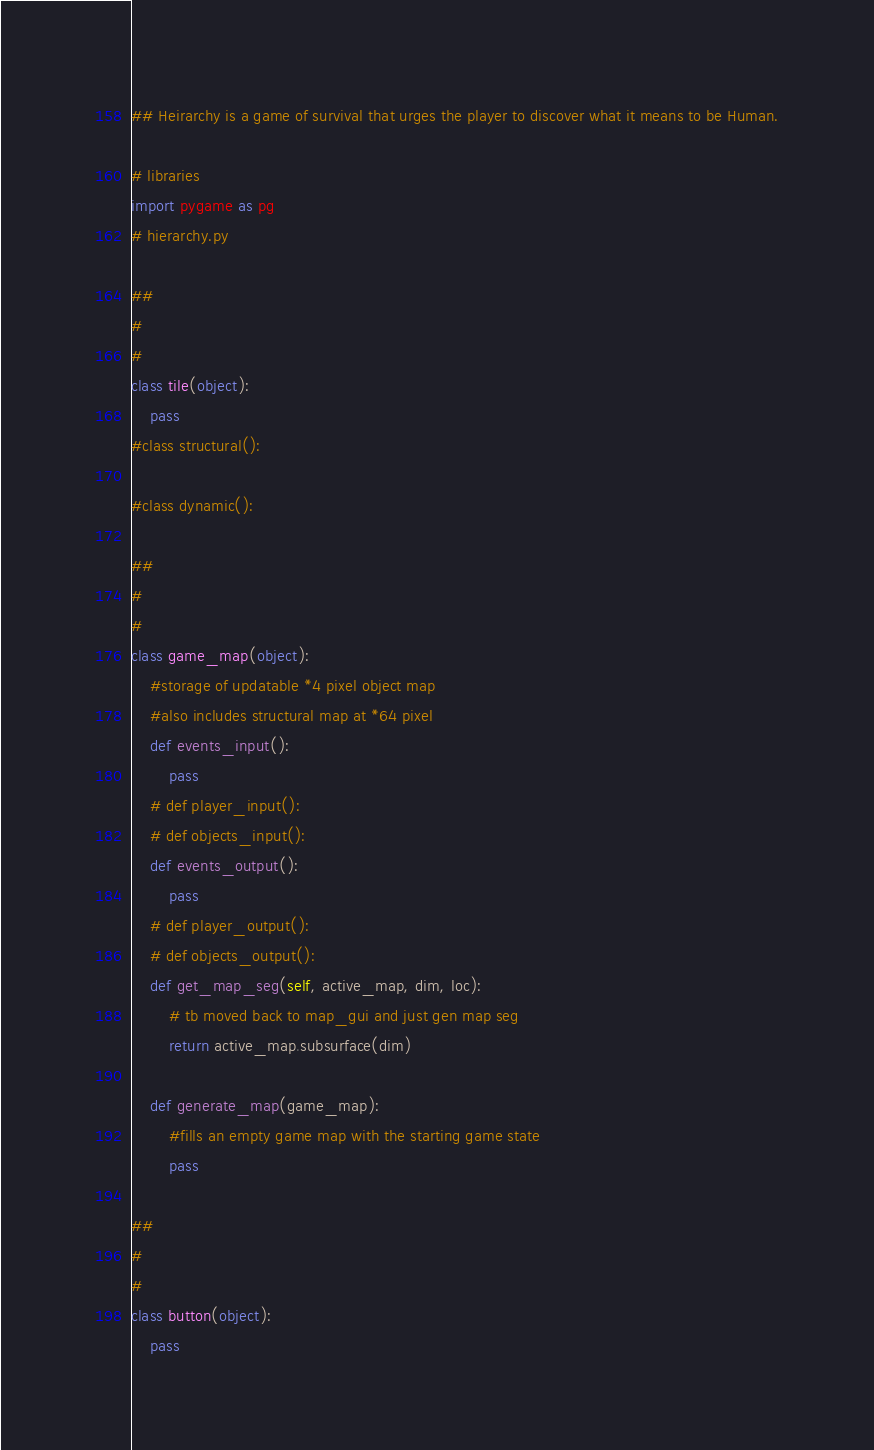<code> <loc_0><loc_0><loc_500><loc_500><_Python_>
## Heirarchy is a game of survival that urges the player to discover what it means to be Human.

# libraries
import pygame as pg
# hierarchy.py

##
#
#
class tile(object):
    pass
#class structural():

#class dynamic():

##
#
#
class game_map(object):
    #storage of updatable *4 pixel object map
    #also includes structural map at *64 pixel
    def events_input():
        pass
    # def player_input():
    # def objects_input():
    def events_output():
        pass
    # def player_output():
    # def objects_output():
    def get_map_seg(self, active_map, dim, loc):
        # tb moved back to map_gui and just gen map seg
        return active_map.subsurface(dim)

    def generate_map(game_map):
        #fills an empty game map with the starting game state
        pass

##
#
#
class button(object):
    pass
</code> 